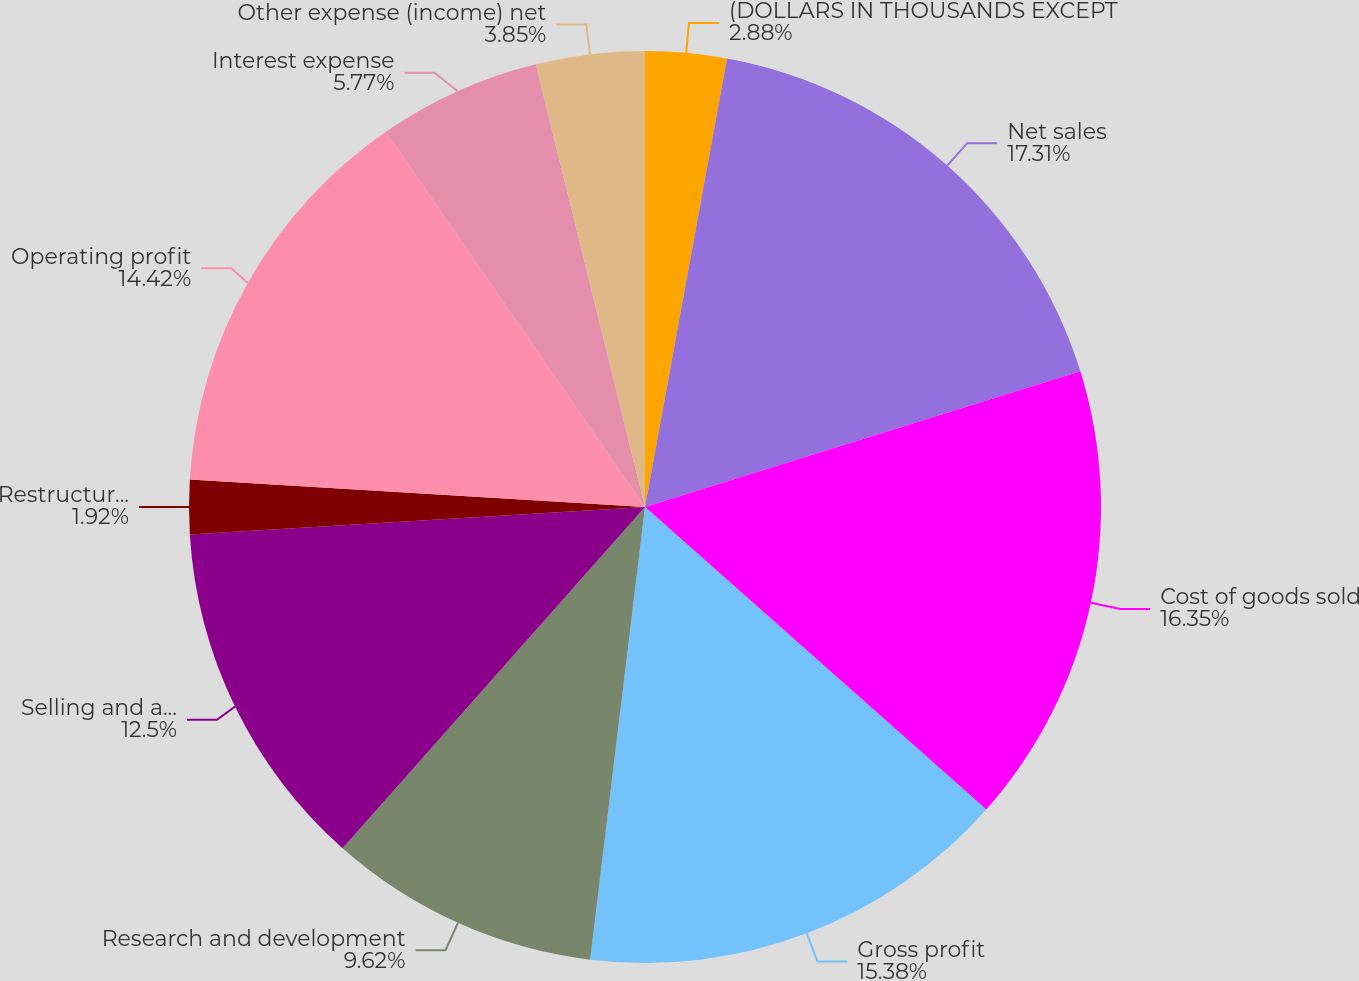Convert chart. <chart><loc_0><loc_0><loc_500><loc_500><pie_chart><fcel>(DOLLARS IN THOUSANDS EXCEPT<fcel>Net sales<fcel>Cost of goods sold<fcel>Gross profit<fcel>Research and development<fcel>Selling and administrative<fcel>Restructuring and other<fcel>Operating profit<fcel>Interest expense<fcel>Other expense (income) net<nl><fcel>2.88%<fcel>17.31%<fcel>16.35%<fcel>15.38%<fcel>9.62%<fcel>12.5%<fcel>1.92%<fcel>14.42%<fcel>5.77%<fcel>3.85%<nl></chart> 